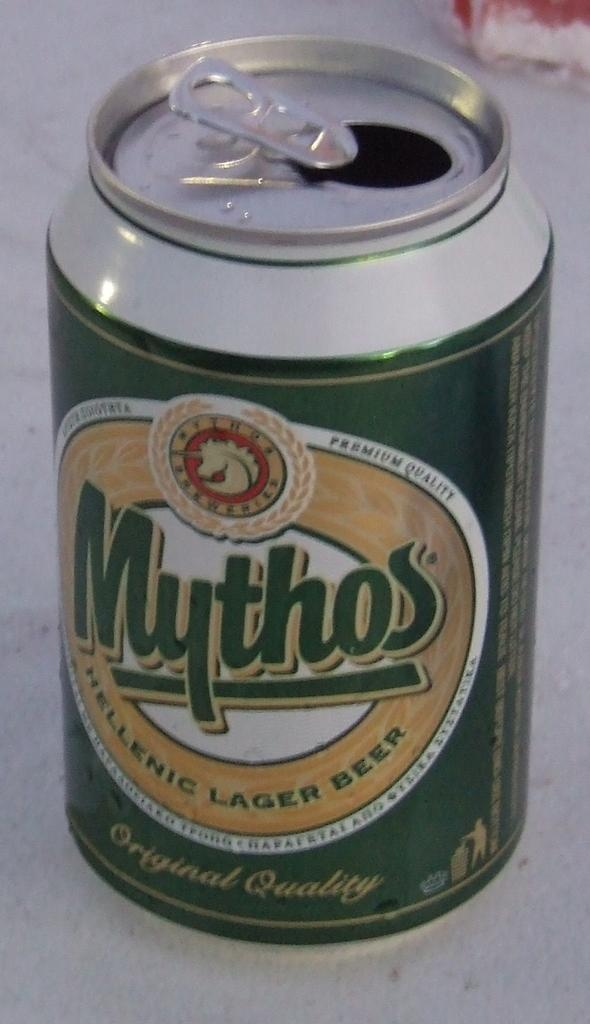<image>
Share a concise interpretation of the image provided. a green and yellow Mythos helenic larger beer can sits on a white table 